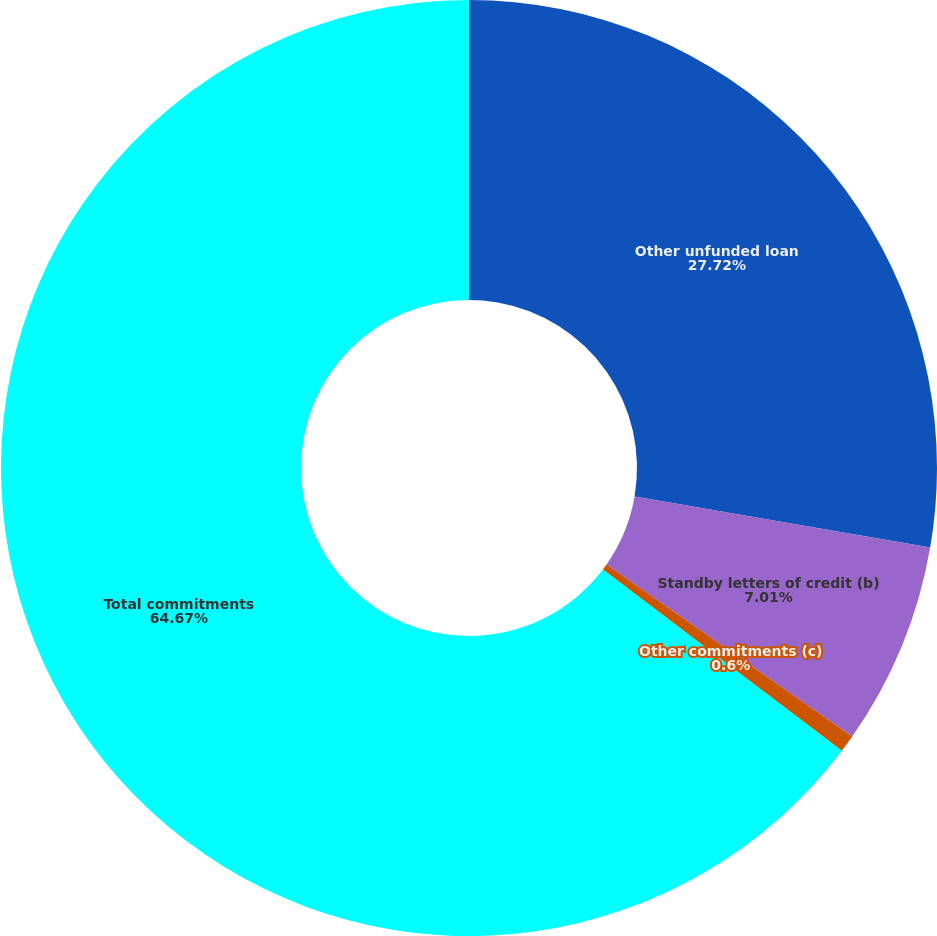<chart> <loc_0><loc_0><loc_500><loc_500><pie_chart><fcel>Other unfunded loan<fcel>Standby letters of credit (b)<fcel>Other commitments (c)<fcel>Total commitments<nl><fcel>27.72%<fcel>7.01%<fcel>0.6%<fcel>64.67%<nl></chart> 